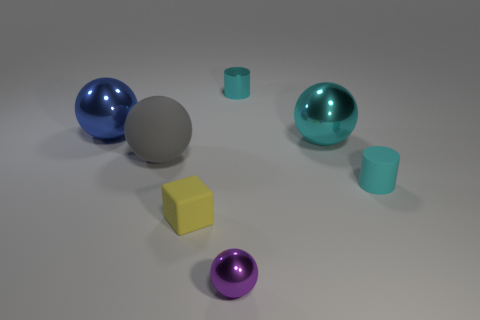Are there any other things that are the same shape as the tiny yellow thing?
Offer a very short reply. No. What number of metallic things are both on the left side of the large cyan shiny thing and behind the small purple shiny thing?
Give a very brief answer. 2. Are there more purple metal balls that are to the left of the matte block than cyan rubber things that are behind the cyan shiny cylinder?
Your response must be concise. No. The cyan matte thing has what size?
Your answer should be compact. Small. Is there another blue object of the same shape as the large matte object?
Give a very brief answer. Yes. Is the shape of the small cyan metallic thing the same as the small thing that is to the right of the cyan metal sphere?
Keep it short and to the point. Yes. There is a thing that is both in front of the small cyan matte thing and on the right side of the block; what is its size?
Ensure brevity in your answer.  Small. What number of cyan things are there?
Provide a succinct answer. 3. There is a ball that is the same size as the yellow thing; what is it made of?
Ensure brevity in your answer.  Metal. Is there a green thing that has the same size as the gray ball?
Provide a short and direct response. No. 